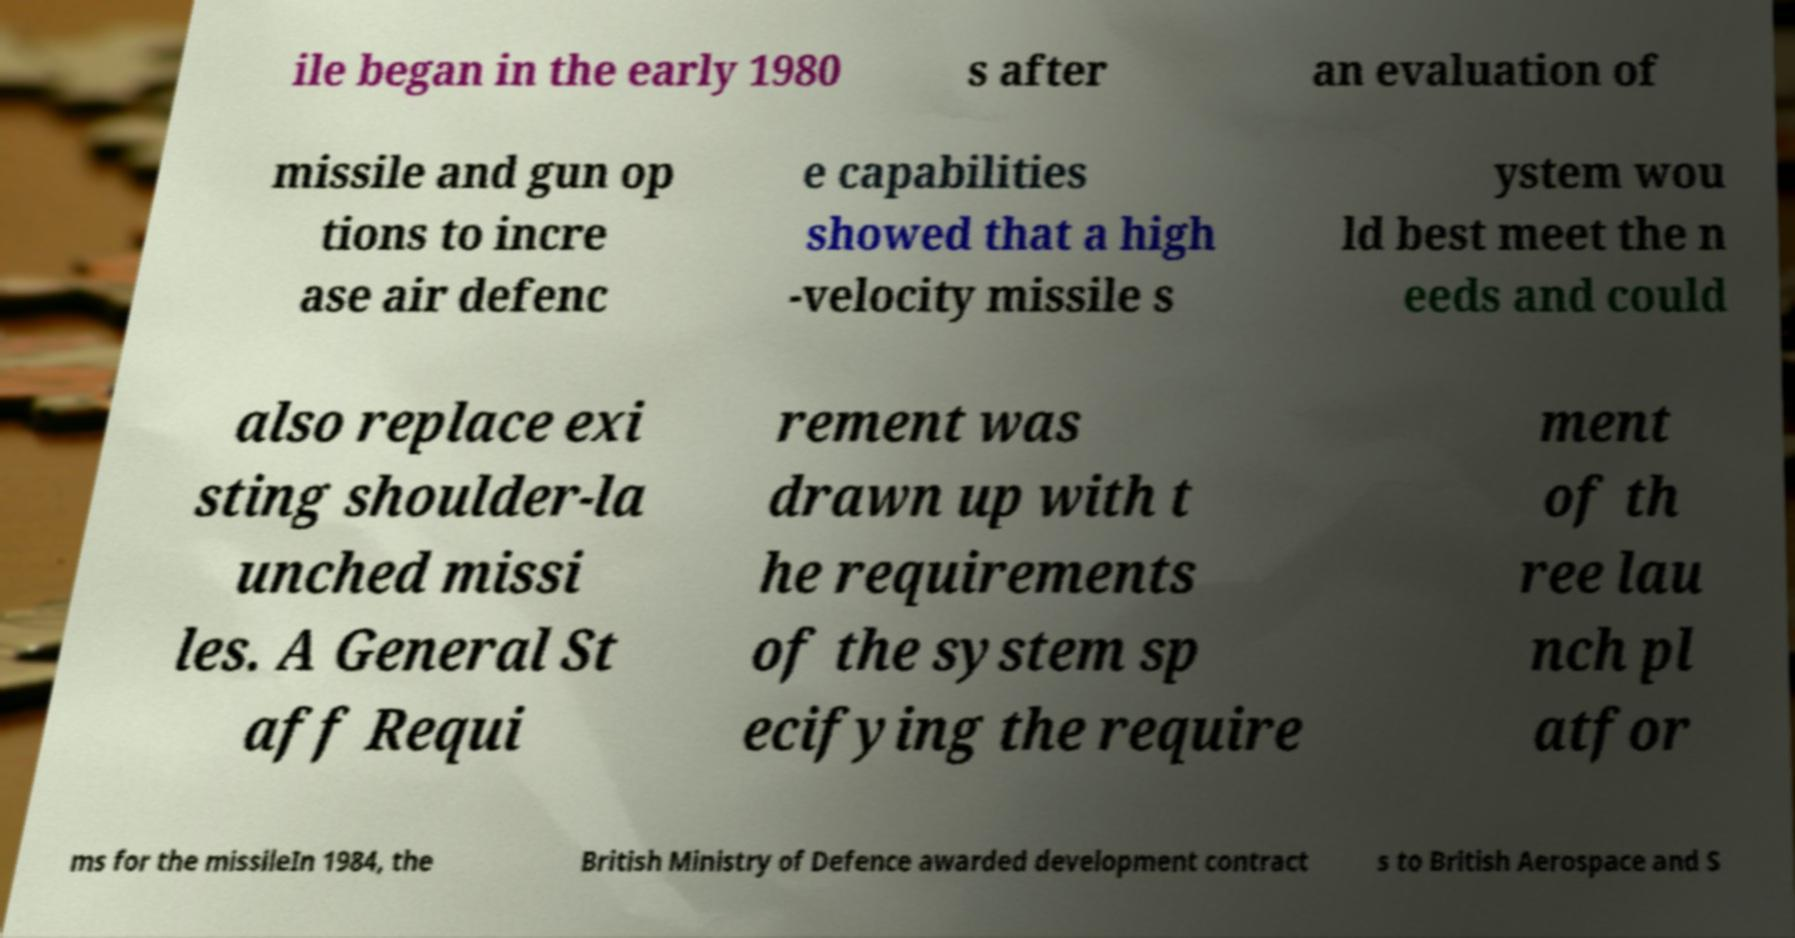For documentation purposes, I need the text within this image transcribed. Could you provide that? ile began in the early 1980 s after an evaluation of missile and gun op tions to incre ase air defenc e capabilities showed that a high -velocity missile s ystem wou ld best meet the n eeds and could also replace exi sting shoulder-la unched missi les. A General St aff Requi rement was drawn up with t he requirements of the system sp ecifying the require ment of th ree lau nch pl atfor ms for the missileIn 1984, the British Ministry of Defence awarded development contract s to British Aerospace and S 